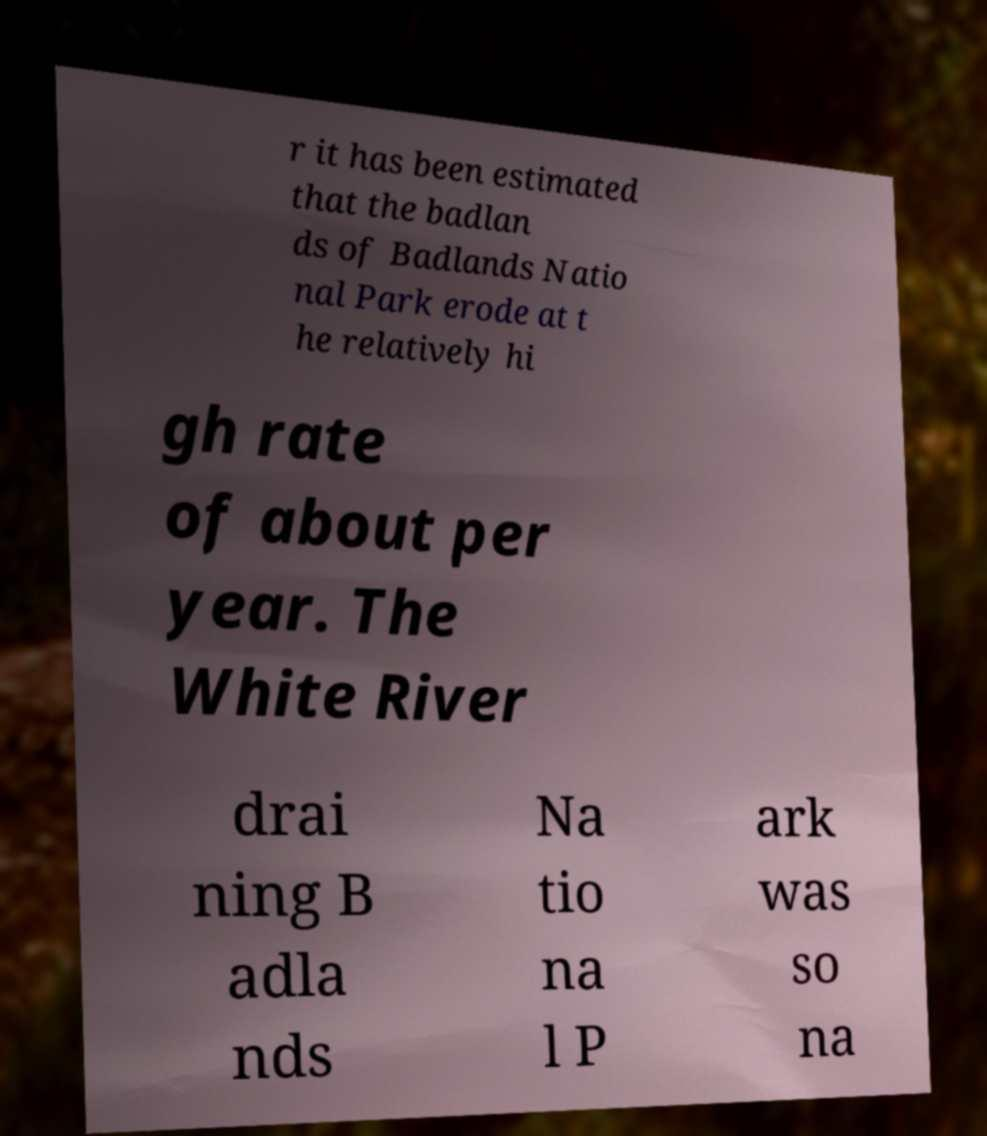Could you extract and type out the text from this image? r it has been estimated that the badlan ds of Badlands Natio nal Park erode at t he relatively hi gh rate of about per year. The White River drai ning B adla nds Na tio na l P ark was so na 